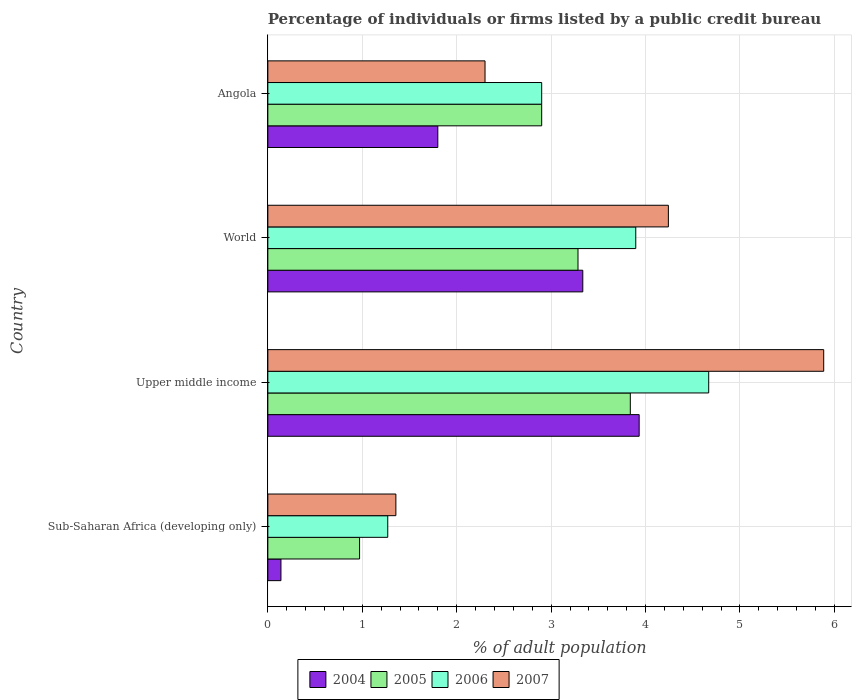How many bars are there on the 3rd tick from the top?
Offer a very short reply. 4. What is the label of the 1st group of bars from the top?
Your response must be concise. Angola. In how many cases, is the number of bars for a given country not equal to the number of legend labels?
Give a very brief answer. 0. What is the percentage of population listed by a public credit bureau in 2007 in Upper middle income?
Ensure brevity in your answer.  5.89. Across all countries, what is the maximum percentage of population listed by a public credit bureau in 2007?
Your answer should be compact. 5.89. Across all countries, what is the minimum percentage of population listed by a public credit bureau in 2005?
Provide a succinct answer. 0.97. In which country was the percentage of population listed by a public credit bureau in 2007 maximum?
Ensure brevity in your answer.  Upper middle income. In which country was the percentage of population listed by a public credit bureau in 2004 minimum?
Your answer should be compact. Sub-Saharan Africa (developing only). What is the total percentage of population listed by a public credit bureau in 2007 in the graph?
Provide a short and direct response. 13.78. What is the difference between the percentage of population listed by a public credit bureau in 2006 in Sub-Saharan Africa (developing only) and that in Upper middle income?
Ensure brevity in your answer.  -3.4. What is the difference between the percentage of population listed by a public credit bureau in 2005 in World and the percentage of population listed by a public credit bureau in 2007 in Angola?
Offer a very short reply. 0.98. What is the average percentage of population listed by a public credit bureau in 2005 per country?
Ensure brevity in your answer.  2.75. What is the difference between the percentage of population listed by a public credit bureau in 2006 and percentage of population listed by a public credit bureau in 2005 in Angola?
Keep it short and to the point. 0. What is the ratio of the percentage of population listed by a public credit bureau in 2004 in Angola to that in World?
Offer a very short reply. 0.54. Is the difference between the percentage of population listed by a public credit bureau in 2006 in Angola and Upper middle income greater than the difference between the percentage of population listed by a public credit bureau in 2005 in Angola and Upper middle income?
Offer a terse response. No. What is the difference between the highest and the second highest percentage of population listed by a public credit bureau in 2005?
Offer a terse response. 0.55. What is the difference between the highest and the lowest percentage of population listed by a public credit bureau in 2006?
Offer a very short reply. 3.4. Is the sum of the percentage of population listed by a public credit bureau in 2006 in Angola and World greater than the maximum percentage of population listed by a public credit bureau in 2007 across all countries?
Offer a terse response. Yes. Is it the case that in every country, the sum of the percentage of population listed by a public credit bureau in 2007 and percentage of population listed by a public credit bureau in 2004 is greater than the sum of percentage of population listed by a public credit bureau in 2005 and percentage of population listed by a public credit bureau in 2006?
Your answer should be compact. No. What does the 4th bar from the top in Sub-Saharan Africa (developing only) represents?
Your answer should be compact. 2004. What does the 4th bar from the bottom in World represents?
Ensure brevity in your answer.  2007. Is it the case that in every country, the sum of the percentage of population listed by a public credit bureau in 2006 and percentage of population listed by a public credit bureau in 2004 is greater than the percentage of population listed by a public credit bureau in 2005?
Give a very brief answer. Yes. Does the graph contain any zero values?
Provide a succinct answer. No. How many legend labels are there?
Your answer should be very brief. 4. What is the title of the graph?
Your answer should be very brief. Percentage of individuals or firms listed by a public credit bureau. Does "1981" appear as one of the legend labels in the graph?
Ensure brevity in your answer.  No. What is the label or title of the X-axis?
Make the answer very short. % of adult population. What is the % of adult population of 2004 in Sub-Saharan Africa (developing only)?
Keep it short and to the point. 0.14. What is the % of adult population of 2005 in Sub-Saharan Africa (developing only)?
Make the answer very short. 0.97. What is the % of adult population of 2006 in Sub-Saharan Africa (developing only)?
Your answer should be compact. 1.27. What is the % of adult population of 2007 in Sub-Saharan Africa (developing only)?
Make the answer very short. 1.36. What is the % of adult population in 2004 in Upper middle income?
Ensure brevity in your answer.  3.93. What is the % of adult population of 2005 in Upper middle income?
Make the answer very short. 3.84. What is the % of adult population in 2006 in Upper middle income?
Keep it short and to the point. 4.67. What is the % of adult population of 2007 in Upper middle income?
Your response must be concise. 5.89. What is the % of adult population of 2004 in World?
Keep it short and to the point. 3.34. What is the % of adult population in 2005 in World?
Your answer should be very brief. 3.28. What is the % of adult population of 2006 in World?
Provide a succinct answer. 3.9. What is the % of adult population in 2007 in World?
Keep it short and to the point. 4.24. What is the % of adult population in 2004 in Angola?
Offer a terse response. 1.8. What is the % of adult population of 2005 in Angola?
Ensure brevity in your answer.  2.9. What is the % of adult population of 2006 in Angola?
Offer a terse response. 2.9. What is the % of adult population of 2007 in Angola?
Give a very brief answer. 2.3. Across all countries, what is the maximum % of adult population in 2004?
Your answer should be compact. 3.93. Across all countries, what is the maximum % of adult population in 2005?
Your answer should be very brief. 3.84. Across all countries, what is the maximum % of adult population in 2006?
Your answer should be compact. 4.67. Across all countries, what is the maximum % of adult population of 2007?
Keep it short and to the point. 5.89. Across all countries, what is the minimum % of adult population of 2004?
Make the answer very short. 0.14. Across all countries, what is the minimum % of adult population in 2005?
Your answer should be very brief. 0.97. Across all countries, what is the minimum % of adult population of 2006?
Make the answer very short. 1.27. Across all countries, what is the minimum % of adult population of 2007?
Provide a short and direct response. 1.36. What is the total % of adult population of 2004 in the graph?
Your answer should be very brief. 9.21. What is the total % of adult population of 2005 in the graph?
Ensure brevity in your answer.  10.99. What is the total % of adult population in 2006 in the graph?
Give a very brief answer. 12.74. What is the total % of adult population of 2007 in the graph?
Your answer should be very brief. 13.78. What is the difference between the % of adult population in 2004 in Sub-Saharan Africa (developing only) and that in Upper middle income?
Your answer should be compact. -3.79. What is the difference between the % of adult population in 2005 in Sub-Saharan Africa (developing only) and that in Upper middle income?
Make the answer very short. -2.87. What is the difference between the % of adult population of 2006 in Sub-Saharan Africa (developing only) and that in Upper middle income?
Ensure brevity in your answer.  -3.4. What is the difference between the % of adult population in 2007 in Sub-Saharan Africa (developing only) and that in Upper middle income?
Your response must be concise. -4.53. What is the difference between the % of adult population of 2004 in Sub-Saharan Africa (developing only) and that in World?
Your answer should be very brief. -3.2. What is the difference between the % of adult population of 2005 in Sub-Saharan Africa (developing only) and that in World?
Keep it short and to the point. -2.31. What is the difference between the % of adult population of 2006 in Sub-Saharan Africa (developing only) and that in World?
Ensure brevity in your answer.  -2.63. What is the difference between the % of adult population in 2007 in Sub-Saharan Africa (developing only) and that in World?
Your answer should be compact. -2.89. What is the difference between the % of adult population of 2004 in Sub-Saharan Africa (developing only) and that in Angola?
Your response must be concise. -1.66. What is the difference between the % of adult population in 2005 in Sub-Saharan Africa (developing only) and that in Angola?
Keep it short and to the point. -1.93. What is the difference between the % of adult population in 2006 in Sub-Saharan Africa (developing only) and that in Angola?
Your answer should be very brief. -1.63. What is the difference between the % of adult population in 2007 in Sub-Saharan Africa (developing only) and that in Angola?
Provide a succinct answer. -0.94. What is the difference between the % of adult population in 2004 in Upper middle income and that in World?
Give a very brief answer. 0.6. What is the difference between the % of adult population in 2005 in Upper middle income and that in World?
Your answer should be compact. 0.55. What is the difference between the % of adult population in 2006 in Upper middle income and that in World?
Offer a terse response. 0.77. What is the difference between the % of adult population of 2007 in Upper middle income and that in World?
Give a very brief answer. 1.64. What is the difference between the % of adult population in 2004 in Upper middle income and that in Angola?
Give a very brief answer. 2.13. What is the difference between the % of adult population in 2005 in Upper middle income and that in Angola?
Make the answer very short. 0.94. What is the difference between the % of adult population of 2006 in Upper middle income and that in Angola?
Provide a short and direct response. 1.77. What is the difference between the % of adult population in 2007 in Upper middle income and that in Angola?
Give a very brief answer. 3.59. What is the difference between the % of adult population of 2004 in World and that in Angola?
Keep it short and to the point. 1.54. What is the difference between the % of adult population in 2005 in World and that in Angola?
Ensure brevity in your answer.  0.38. What is the difference between the % of adult population in 2006 in World and that in Angola?
Offer a terse response. 1. What is the difference between the % of adult population in 2007 in World and that in Angola?
Your answer should be very brief. 1.94. What is the difference between the % of adult population in 2004 in Sub-Saharan Africa (developing only) and the % of adult population in 2005 in Upper middle income?
Give a very brief answer. -3.7. What is the difference between the % of adult population of 2004 in Sub-Saharan Africa (developing only) and the % of adult population of 2006 in Upper middle income?
Offer a terse response. -4.53. What is the difference between the % of adult population in 2004 in Sub-Saharan Africa (developing only) and the % of adult population in 2007 in Upper middle income?
Keep it short and to the point. -5.75. What is the difference between the % of adult population in 2005 in Sub-Saharan Africa (developing only) and the % of adult population in 2006 in Upper middle income?
Ensure brevity in your answer.  -3.7. What is the difference between the % of adult population of 2005 in Sub-Saharan Africa (developing only) and the % of adult population of 2007 in Upper middle income?
Provide a short and direct response. -4.92. What is the difference between the % of adult population in 2006 in Sub-Saharan Africa (developing only) and the % of adult population in 2007 in Upper middle income?
Offer a very short reply. -4.62. What is the difference between the % of adult population of 2004 in Sub-Saharan Africa (developing only) and the % of adult population of 2005 in World?
Offer a very short reply. -3.15. What is the difference between the % of adult population of 2004 in Sub-Saharan Africa (developing only) and the % of adult population of 2006 in World?
Keep it short and to the point. -3.76. What is the difference between the % of adult population in 2004 in Sub-Saharan Africa (developing only) and the % of adult population in 2007 in World?
Offer a terse response. -4.1. What is the difference between the % of adult population in 2005 in Sub-Saharan Africa (developing only) and the % of adult population in 2006 in World?
Keep it short and to the point. -2.92. What is the difference between the % of adult population of 2005 in Sub-Saharan Africa (developing only) and the % of adult population of 2007 in World?
Offer a terse response. -3.27. What is the difference between the % of adult population in 2006 in Sub-Saharan Africa (developing only) and the % of adult population in 2007 in World?
Offer a very short reply. -2.97. What is the difference between the % of adult population in 2004 in Sub-Saharan Africa (developing only) and the % of adult population in 2005 in Angola?
Offer a very short reply. -2.76. What is the difference between the % of adult population of 2004 in Sub-Saharan Africa (developing only) and the % of adult population of 2006 in Angola?
Keep it short and to the point. -2.76. What is the difference between the % of adult population in 2004 in Sub-Saharan Africa (developing only) and the % of adult population in 2007 in Angola?
Your answer should be very brief. -2.16. What is the difference between the % of adult population of 2005 in Sub-Saharan Africa (developing only) and the % of adult population of 2006 in Angola?
Give a very brief answer. -1.93. What is the difference between the % of adult population in 2005 in Sub-Saharan Africa (developing only) and the % of adult population in 2007 in Angola?
Your answer should be compact. -1.33. What is the difference between the % of adult population in 2006 in Sub-Saharan Africa (developing only) and the % of adult population in 2007 in Angola?
Offer a very short reply. -1.03. What is the difference between the % of adult population in 2004 in Upper middle income and the % of adult population in 2005 in World?
Your response must be concise. 0.65. What is the difference between the % of adult population in 2004 in Upper middle income and the % of adult population in 2006 in World?
Keep it short and to the point. 0.04. What is the difference between the % of adult population in 2004 in Upper middle income and the % of adult population in 2007 in World?
Give a very brief answer. -0.31. What is the difference between the % of adult population of 2005 in Upper middle income and the % of adult population of 2006 in World?
Keep it short and to the point. -0.06. What is the difference between the % of adult population in 2005 in Upper middle income and the % of adult population in 2007 in World?
Keep it short and to the point. -0.4. What is the difference between the % of adult population in 2006 in Upper middle income and the % of adult population in 2007 in World?
Give a very brief answer. 0.43. What is the difference between the % of adult population of 2004 in Upper middle income and the % of adult population of 2005 in Angola?
Provide a succinct answer. 1.03. What is the difference between the % of adult population of 2004 in Upper middle income and the % of adult population of 2006 in Angola?
Your answer should be compact. 1.03. What is the difference between the % of adult population of 2004 in Upper middle income and the % of adult population of 2007 in Angola?
Make the answer very short. 1.63. What is the difference between the % of adult population of 2005 in Upper middle income and the % of adult population of 2006 in Angola?
Offer a terse response. 0.94. What is the difference between the % of adult population in 2005 in Upper middle income and the % of adult population in 2007 in Angola?
Make the answer very short. 1.54. What is the difference between the % of adult population of 2006 in Upper middle income and the % of adult population of 2007 in Angola?
Give a very brief answer. 2.37. What is the difference between the % of adult population in 2004 in World and the % of adult population in 2005 in Angola?
Your answer should be very brief. 0.44. What is the difference between the % of adult population of 2004 in World and the % of adult population of 2006 in Angola?
Give a very brief answer. 0.44. What is the difference between the % of adult population in 2004 in World and the % of adult population in 2007 in Angola?
Provide a succinct answer. 1.04. What is the difference between the % of adult population in 2005 in World and the % of adult population in 2006 in Angola?
Your response must be concise. 0.38. What is the difference between the % of adult population in 2005 in World and the % of adult population in 2007 in Angola?
Ensure brevity in your answer.  0.98. What is the difference between the % of adult population in 2006 in World and the % of adult population in 2007 in Angola?
Your response must be concise. 1.6. What is the average % of adult population of 2004 per country?
Ensure brevity in your answer.  2.3. What is the average % of adult population in 2005 per country?
Your answer should be very brief. 2.75. What is the average % of adult population in 2006 per country?
Offer a very short reply. 3.18. What is the average % of adult population of 2007 per country?
Your answer should be compact. 3.45. What is the difference between the % of adult population in 2004 and % of adult population in 2005 in Sub-Saharan Africa (developing only)?
Keep it short and to the point. -0.83. What is the difference between the % of adult population of 2004 and % of adult population of 2006 in Sub-Saharan Africa (developing only)?
Ensure brevity in your answer.  -1.13. What is the difference between the % of adult population in 2004 and % of adult population in 2007 in Sub-Saharan Africa (developing only)?
Offer a terse response. -1.22. What is the difference between the % of adult population of 2005 and % of adult population of 2006 in Sub-Saharan Africa (developing only)?
Your answer should be very brief. -0.3. What is the difference between the % of adult population in 2005 and % of adult population in 2007 in Sub-Saharan Africa (developing only)?
Offer a terse response. -0.38. What is the difference between the % of adult population in 2006 and % of adult population in 2007 in Sub-Saharan Africa (developing only)?
Your answer should be very brief. -0.09. What is the difference between the % of adult population in 2004 and % of adult population in 2005 in Upper middle income?
Keep it short and to the point. 0.09. What is the difference between the % of adult population in 2004 and % of adult population in 2006 in Upper middle income?
Offer a very short reply. -0.74. What is the difference between the % of adult population in 2004 and % of adult population in 2007 in Upper middle income?
Provide a short and direct response. -1.95. What is the difference between the % of adult population of 2005 and % of adult population of 2006 in Upper middle income?
Provide a succinct answer. -0.83. What is the difference between the % of adult population of 2005 and % of adult population of 2007 in Upper middle income?
Your answer should be very brief. -2.05. What is the difference between the % of adult population in 2006 and % of adult population in 2007 in Upper middle income?
Provide a short and direct response. -1.22. What is the difference between the % of adult population in 2004 and % of adult population in 2005 in World?
Your response must be concise. 0.05. What is the difference between the % of adult population of 2004 and % of adult population of 2006 in World?
Offer a very short reply. -0.56. What is the difference between the % of adult population in 2004 and % of adult population in 2007 in World?
Your answer should be very brief. -0.91. What is the difference between the % of adult population of 2005 and % of adult population of 2006 in World?
Make the answer very short. -0.61. What is the difference between the % of adult population in 2005 and % of adult population in 2007 in World?
Provide a succinct answer. -0.96. What is the difference between the % of adult population in 2006 and % of adult population in 2007 in World?
Make the answer very short. -0.35. What is the difference between the % of adult population of 2004 and % of adult population of 2006 in Angola?
Your answer should be very brief. -1.1. What is the ratio of the % of adult population in 2004 in Sub-Saharan Africa (developing only) to that in Upper middle income?
Your response must be concise. 0.04. What is the ratio of the % of adult population of 2005 in Sub-Saharan Africa (developing only) to that in Upper middle income?
Your response must be concise. 0.25. What is the ratio of the % of adult population in 2006 in Sub-Saharan Africa (developing only) to that in Upper middle income?
Give a very brief answer. 0.27. What is the ratio of the % of adult population in 2007 in Sub-Saharan Africa (developing only) to that in Upper middle income?
Keep it short and to the point. 0.23. What is the ratio of the % of adult population in 2004 in Sub-Saharan Africa (developing only) to that in World?
Offer a very short reply. 0.04. What is the ratio of the % of adult population in 2005 in Sub-Saharan Africa (developing only) to that in World?
Your answer should be compact. 0.3. What is the ratio of the % of adult population of 2006 in Sub-Saharan Africa (developing only) to that in World?
Your answer should be compact. 0.33. What is the ratio of the % of adult population in 2007 in Sub-Saharan Africa (developing only) to that in World?
Provide a succinct answer. 0.32. What is the ratio of the % of adult population of 2004 in Sub-Saharan Africa (developing only) to that in Angola?
Your answer should be compact. 0.08. What is the ratio of the % of adult population of 2005 in Sub-Saharan Africa (developing only) to that in Angola?
Provide a succinct answer. 0.34. What is the ratio of the % of adult population of 2006 in Sub-Saharan Africa (developing only) to that in Angola?
Your answer should be compact. 0.44. What is the ratio of the % of adult population in 2007 in Sub-Saharan Africa (developing only) to that in Angola?
Offer a very short reply. 0.59. What is the ratio of the % of adult population in 2004 in Upper middle income to that in World?
Your answer should be very brief. 1.18. What is the ratio of the % of adult population in 2005 in Upper middle income to that in World?
Provide a short and direct response. 1.17. What is the ratio of the % of adult population of 2006 in Upper middle income to that in World?
Give a very brief answer. 1.2. What is the ratio of the % of adult population in 2007 in Upper middle income to that in World?
Give a very brief answer. 1.39. What is the ratio of the % of adult population in 2004 in Upper middle income to that in Angola?
Give a very brief answer. 2.18. What is the ratio of the % of adult population in 2005 in Upper middle income to that in Angola?
Your response must be concise. 1.32. What is the ratio of the % of adult population in 2006 in Upper middle income to that in Angola?
Your answer should be very brief. 1.61. What is the ratio of the % of adult population in 2007 in Upper middle income to that in Angola?
Ensure brevity in your answer.  2.56. What is the ratio of the % of adult population in 2004 in World to that in Angola?
Your answer should be very brief. 1.85. What is the ratio of the % of adult population in 2005 in World to that in Angola?
Keep it short and to the point. 1.13. What is the ratio of the % of adult population of 2006 in World to that in Angola?
Ensure brevity in your answer.  1.34. What is the ratio of the % of adult population of 2007 in World to that in Angola?
Keep it short and to the point. 1.84. What is the difference between the highest and the second highest % of adult population in 2004?
Provide a succinct answer. 0.6. What is the difference between the highest and the second highest % of adult population of 2005?
Provide a succinct answer. 0.55. What is the difference between the highest and the second highest % of adult population in 2006?
Ensure brevity in your answer.  0.77. What is the difference between the highest and the second highest % of adult population in 2007?
Give a very brief answer. 1.64. What is the difference between the highest and the lowest % of adult population in 2004?
Give a very brief answer. 3.79. What is the difference between the highest and the lowest % of adult population of 2005?
Ensure brevity in your answer.  2.87. What is the difference between the highest and the lowest % of adult population of 2006?
Your response must be concise. 3.4. What is the difference between the highest and the lowest % of adult population of 2007?
Your answer should be very brief. 4.53. 